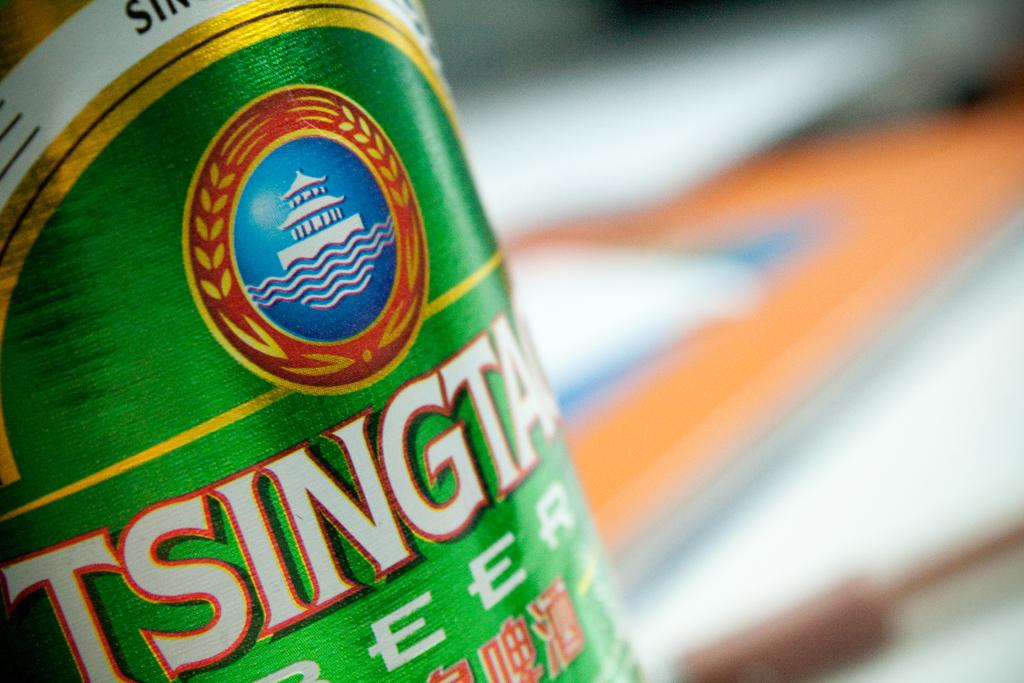What can be observed about the background of the image? The background of the image is blurred. What is located on the left side of the image? There is a bottle on the left side of the image. What feature does the bottle have? The bottle has a label on it. What information is present on the label? There is text and an image on the label. What type of lumber is being used to build the organization's headquarters in the image? There is no mention of lumber or an organization's headquarters in the image; it features a bottle with a label. How many seeds can be seen growing in the image? There are no seeds present in the image. 